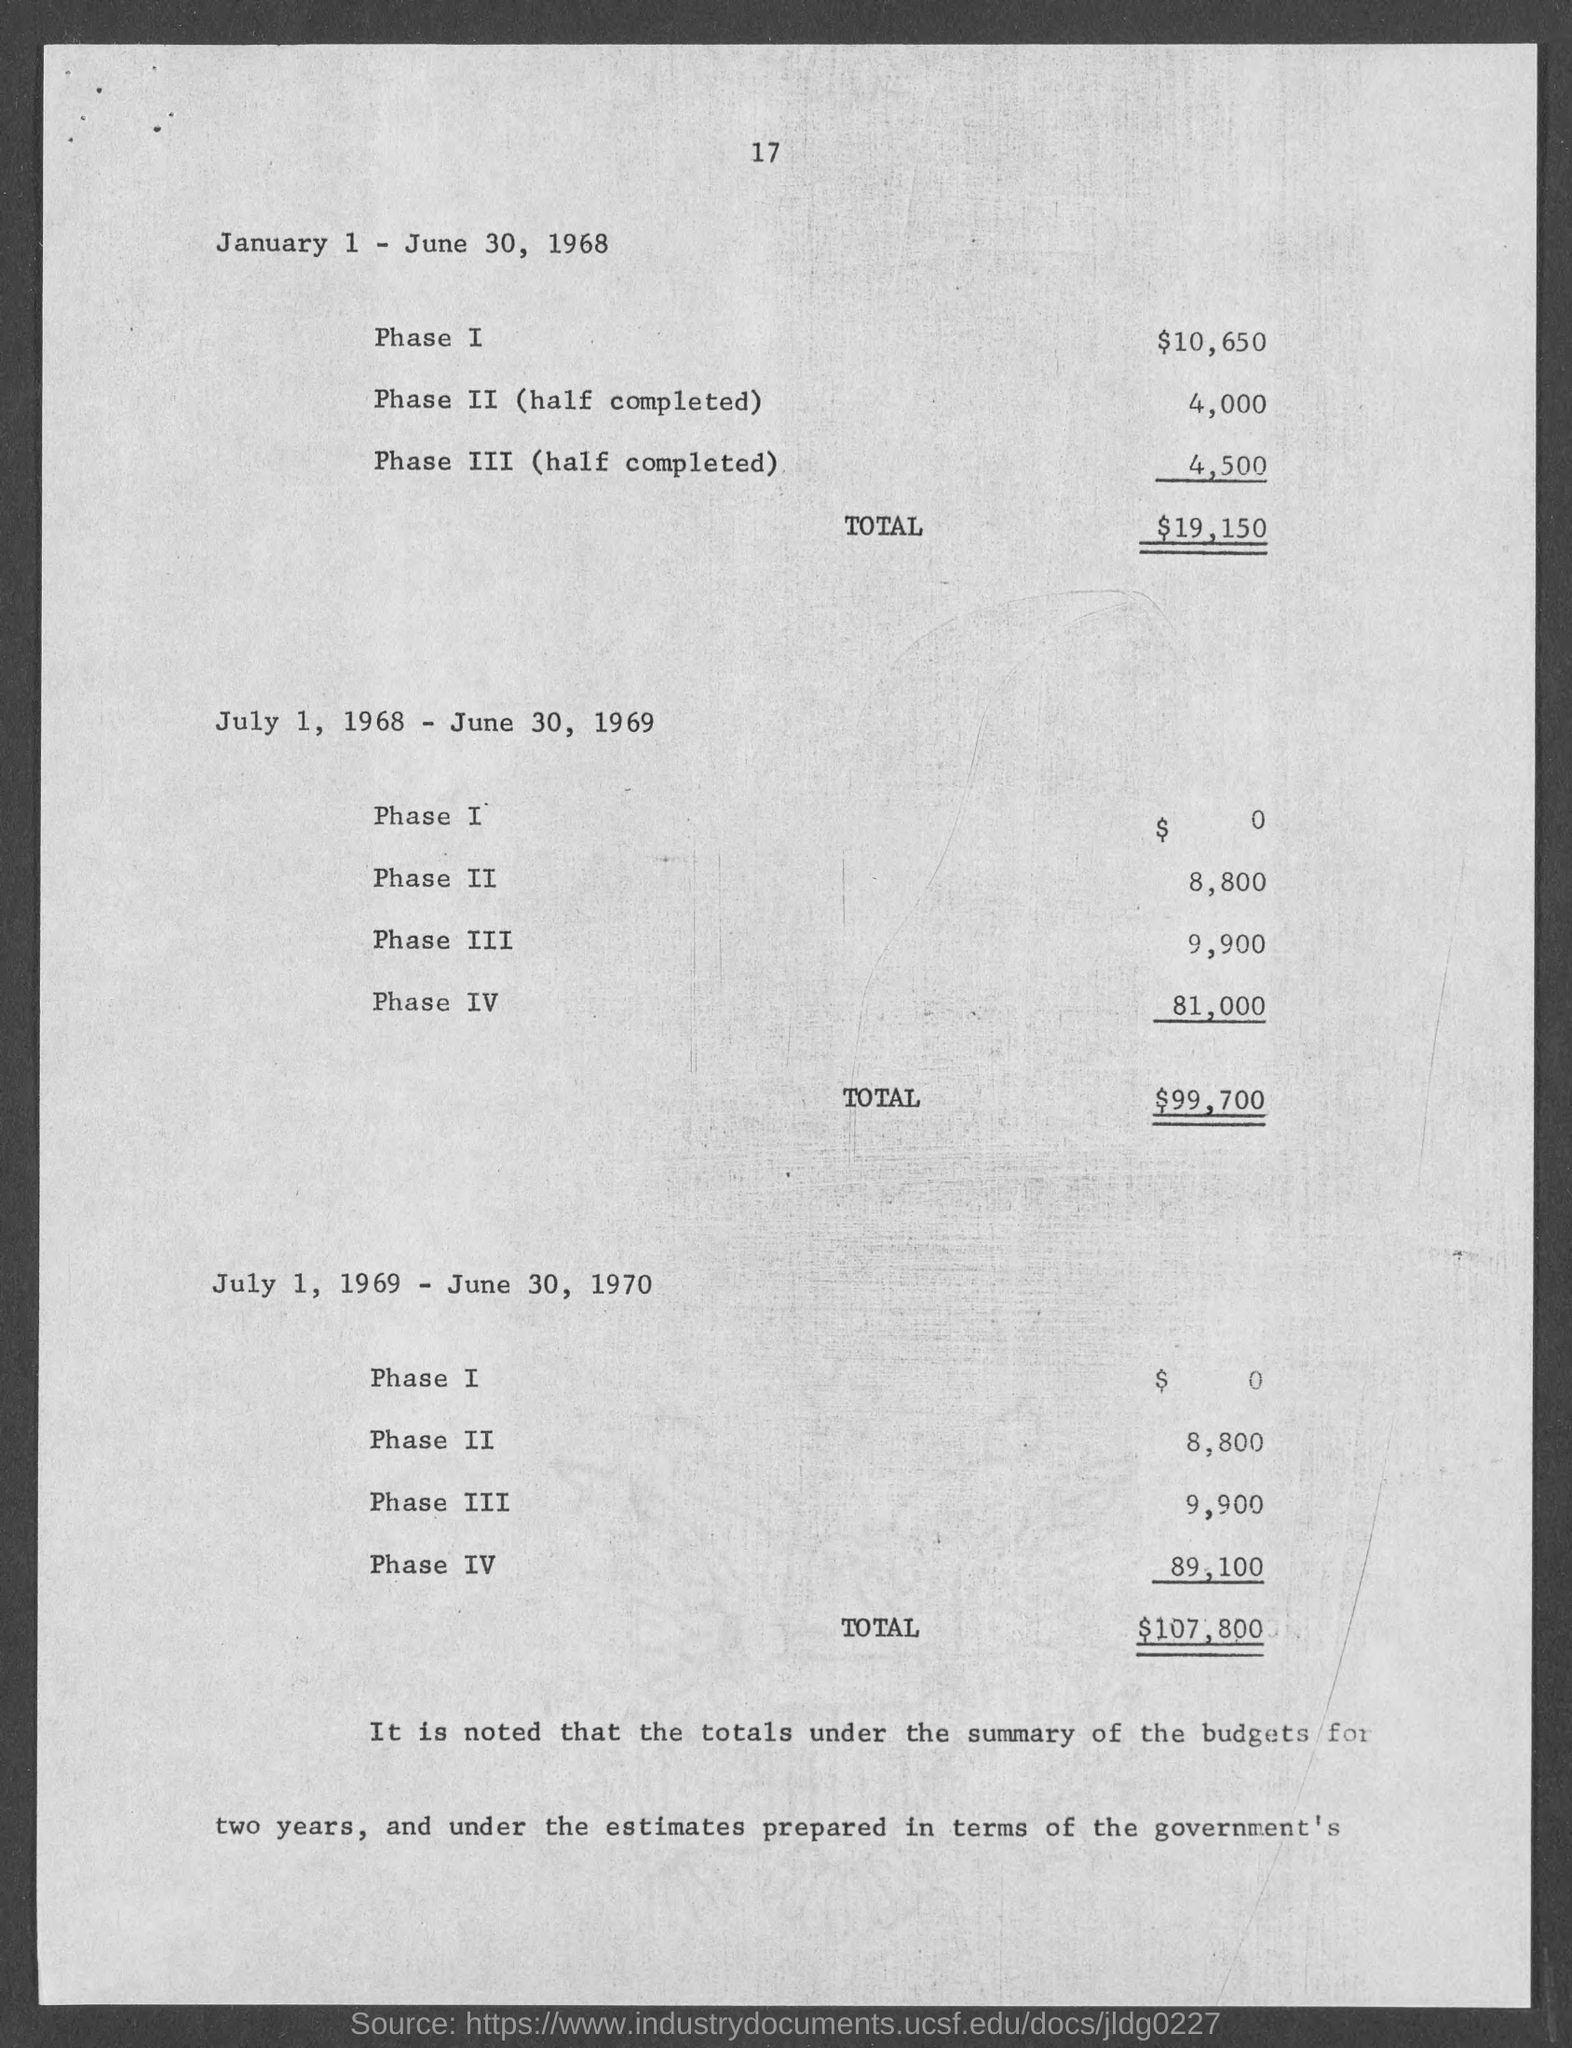Point out several critical features in this image. The total for July 1, 1969 to June 30, 1970 was $107,800. The cost of Phase II for the period of July 1, 1968 - June 30, 1969 was $8,800. The cost of Phase III for the period of July 1, 1968 through June 30, 1969 was $9,900. The total for July 1, 1968 to June 30, 1969 is 99,700. The cost of Phase II, which was half completed between January 1 and June 30, 1968, was 4,000. 